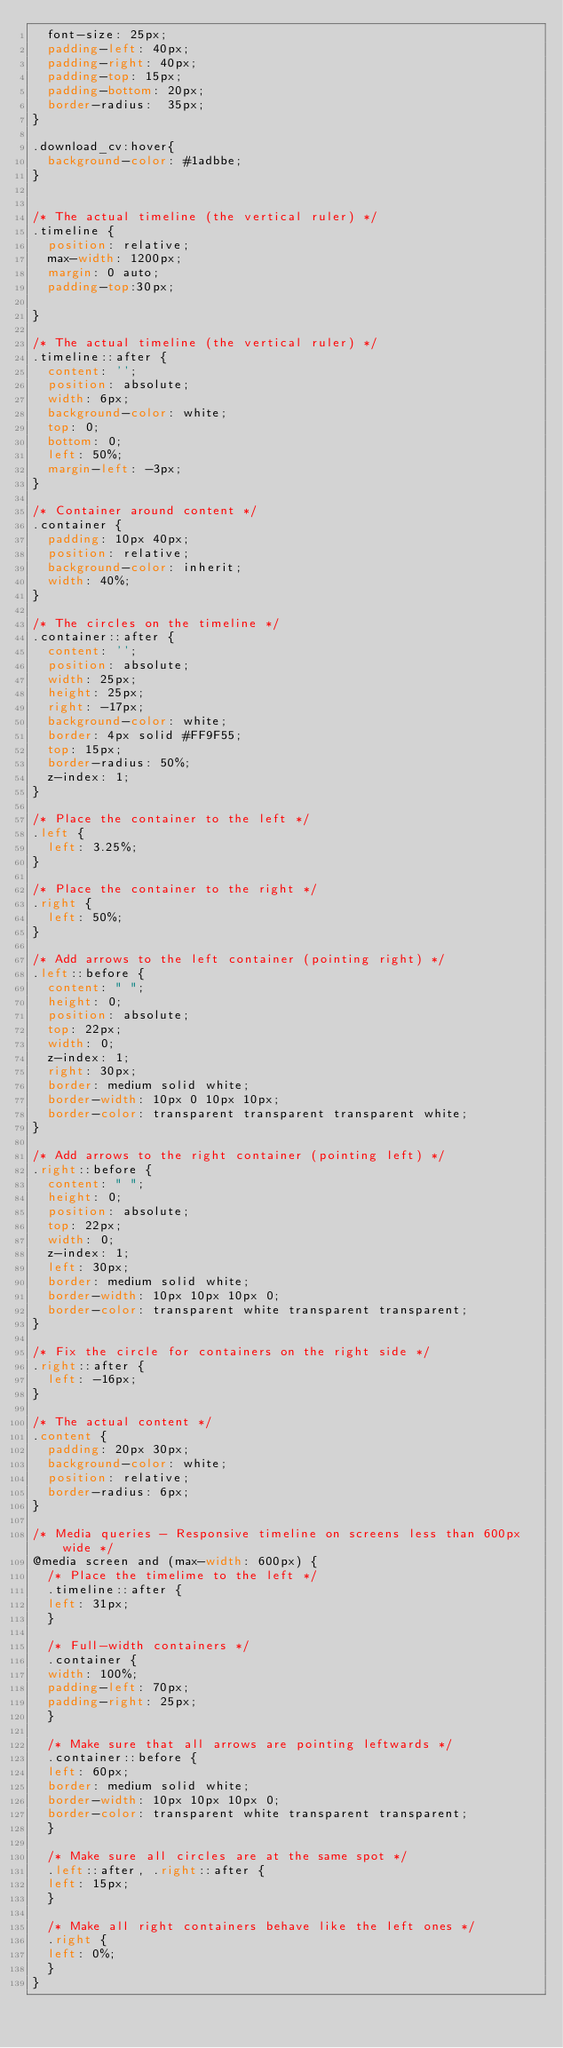Convert code to text. <code><loc_0><loc_0><loc_500><loc_500><_CSS_>  font-size: 25px;
  padding-left: 40px;
  padding-right: 40px;
  padding-top: 15px;
  padding-bottom: 20px;
  border-radius:  35px;
}

.download_cv:hover{
  background-color: #1adbbe;
}


/* The actual timeline (the vertical ruler) */
.timeline {
  position: relative;
  max-width: 1200px;
  margin: 0 auto;
  padding-top:30px;
  
}

/* The actual timeline (the vertical ruler) */
.timeline::after {
  content: '';
  position: absolute;
  width: 6px;
  background-color: white;
  top: 0;
  bottom: 0;
  left: 50%;
  margin-left: -3px;
}

/* Container around content */
.container {
  padding: 10px 40px;
  position: relative;
  background-color: inherit;
  width: 40%;
}

/* The circles on the timeline */
.container::after {
  content: '';
  position: absolute;
  width: 25px;
  height: 25px;
  right: -17px;
  background-color: white;
  border: 4px solid #FF9F55;
  top: 15px;
  border-radius: 50%;
  z-index: 1;
}

/* Place the container to the left */
.left {
  left: 3.25%;
}

/* Place the container to the right */
.right {
  left: 50%;
}

/* Add arrows to the left container (pointing right) */
.left::before {
  content: " ";
  height: 0;
  position: absolute;
  top: 22px;
  width: 0;
  z-index: 1;
  right: 30px;
  border: medium solid white;
  border-width: 10px 0 10px 10px;
  border-color: transparent transparent transparent white;
}

/* Add arrows to the right container (pointing left) */
.right::before {
  content: " ";
  height: 0;
  position: absolute;
  top: 22px;
  width: 0;
  z-index: 1;
  left: 30px;
  border: medium solid white;
  border-width: 10px 10px 10px 0;
  border-color: transparent white transparent transparent;
}

/* Fix the circle for containers on the right side */
.right::after {
  left: -16px;
}

/* The actual content */
.content {
  padding: 20px 30px;
  background-color: white;
  position: relative;
  border-radius: 6px;
}

/* Media queries - Responsive timeline on screens less than 600px wide */
@media screen and (max-width: 600px) {
  /* Place the timelime to the left */
  .timeline::after {
  left: 31px;
  }
  
  /* Full-width containers */
  .container {
  width: 100%;
  padding-left: 70px;
  padding-right: 25px;
  }
  
  /* Make sure that all arrows are pointing leftwards */
  .container::before {
  left: 60px;
  border: medium solid white;
  border-width: 10px 10px 10px 0;
  border-color: transparent white transparent transparent;
  }

  /* Make sure all circles are at the same spot */
  .left::after, .right::after {
  left: 15px;
  }
  
  /* Make all right containers behave like the left ones */
  .right {
  left: 0%;
  }
}</code> 